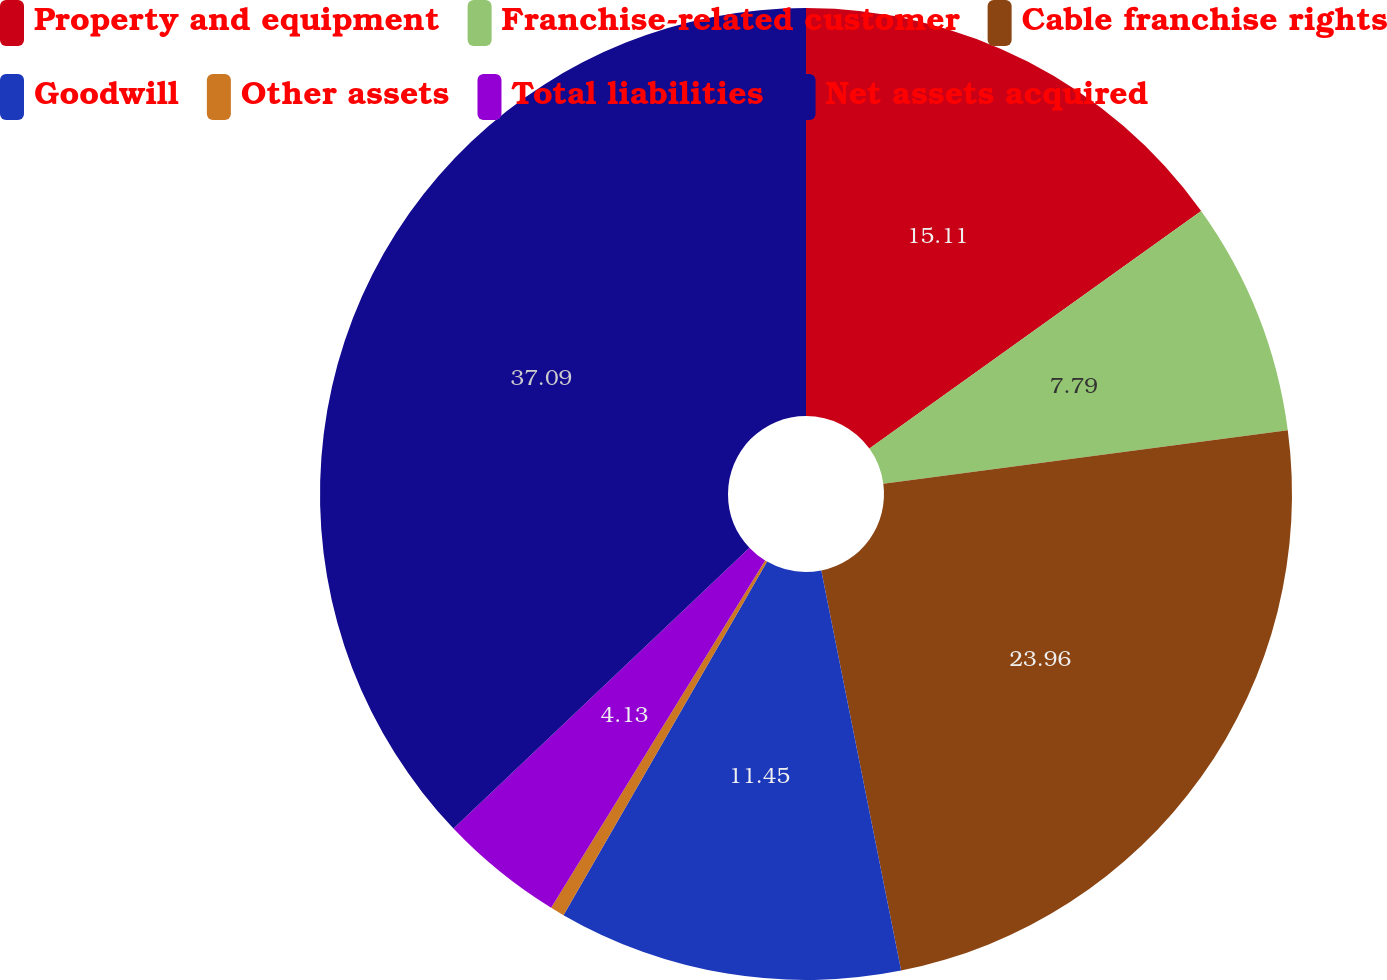Convert chart to OTSL. <chart><loc_0><loc_0><loc_500><loc_500><pie_chart><fcel>Property and equipment<fcel>Franchise-related customer<fcel>Cable franchise rights<fcel>Goodwill<fcel>Other assets<fcel>Total liabilities<fcel>Net assets acquired<nl><fcel>15.11%<fcel>7.79%<fcel>23.96%<fcel>11.45%<fcel>0.47%<fcel>4.13%<fcel>37.08%<nl></chart> 